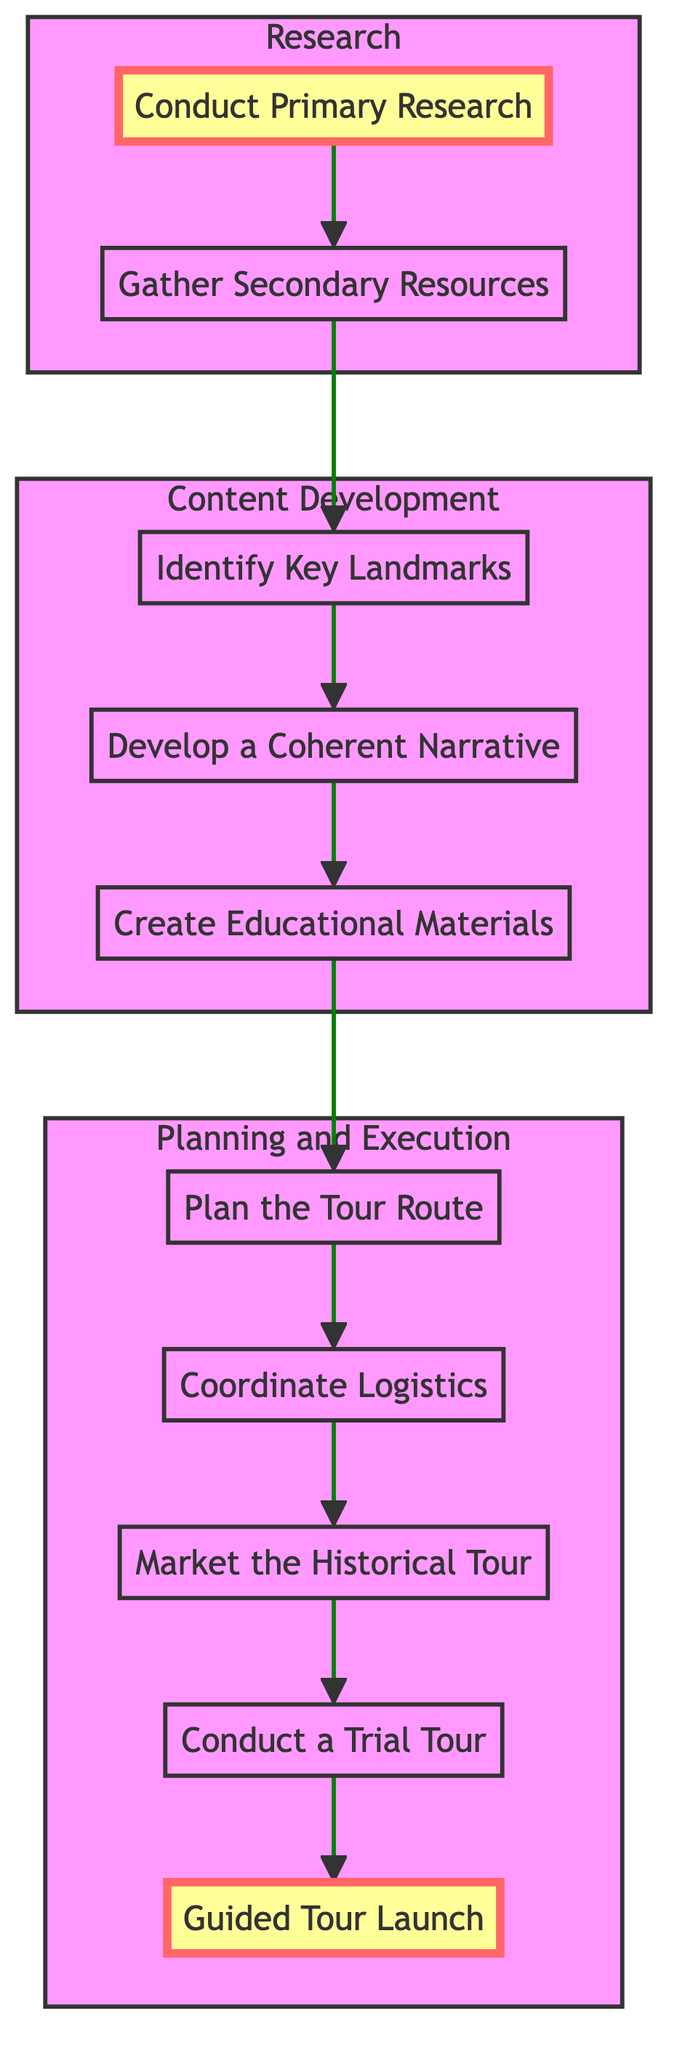What is the first activity in the diagram? The diagram shows that the first activity is located at the bottom, labeled "Conduct Primary Research." This is the starting point for the entire process of organizing the historical tour.
Answer: Conduct Primary Research How many main activities are listed in the diagram? Counting from the bottom to the top, there are a total of ten main activities represented in the diagram, each having a distinct role in the process.
Answer: Ten What activity directly follows "Identify Key Landmarks"? By examining the flow from the bottom to the top, "Identify Key Landmarks" leads directly to the next activity, which is "Develop a Coherent Narrative." This relationship shows the sequential development of the tour planning process.
Answer: Develop a Coherent Narrative Which two activities fall under the "Content Development" subgraph? The activities within the "Content Development" subgraph, identified as part of the middle section of the diagram flow, are "Identify Key Landmarks" and "Create Educational Materials." These activities are integral to developing the content of the tour.
Answer: Identify Key Landmarks and Create Educational Materials What is the last activity shown in the diagram? The last activity at the top of the flow chart is "Guided Tour Launch," indicating the completion of all prior steps leading to this final event.
Answer: Guided Tour Launch How many sub-steps are involved in the "Conduct a Trial Tour"? Within the "Conduct a Trial Tour" activity, there are two specific subtasks listed: inviting community members for feedback and making necessary adjustments based on their observations. This indicates a focused review process after the preliminary tour.
Answer: Two Which activity precedes "Market the Historical Tour"? The activity that precedes "Market the Historical Tour" is "Coordinate Logistics." This implies that logistical arrangements need to be settled before effectively marketing the tour to potential participants.
Answer: Coordinate Logistics What is the purpose of "Gather Secondary Resources"? The purpose of "Gather Secondary Resources" involves collecting various published and archival materials to supplement the primary research, thus enriching the historical context and depth of the tour.
Answer: Enriching historical context How does "Create Educational Materials" contribute to the overall process? "Create Educational Materials" contributes by designing brochures and preparing visual aids, which assist in presenting the historical narrative engagingly and informatively, ensuring a better experience for participants.
Answer: Assist in presentation What connects all activities in the flowchart? All activities in the flowchart are connected through a directed flow that ensures a logical progression from research to the final launch, illustrating a structured approach to organizing the tour.
Answer: Directed flow 